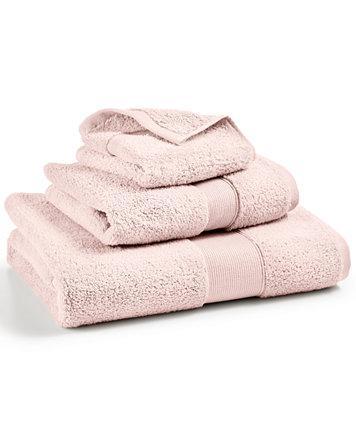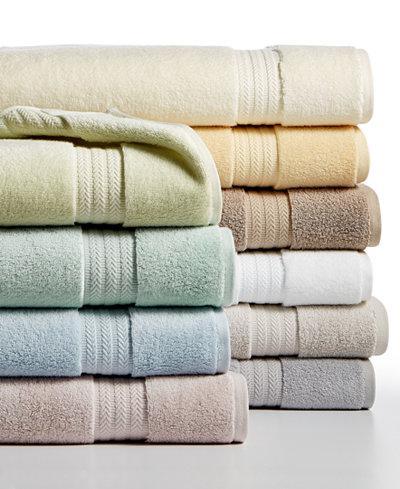The first image is the image on the left, the second image is the image on the right. Examine the images to the left and right. Is the description "There are two stacks of towels in the image on the right." accurate? Answer yes or no. Yes. The first image is the image on the left, the second image is the image on the right. For the images shown, is this caption "The corners are pulled up on two towels." true? Answer yes or no. Yes. 